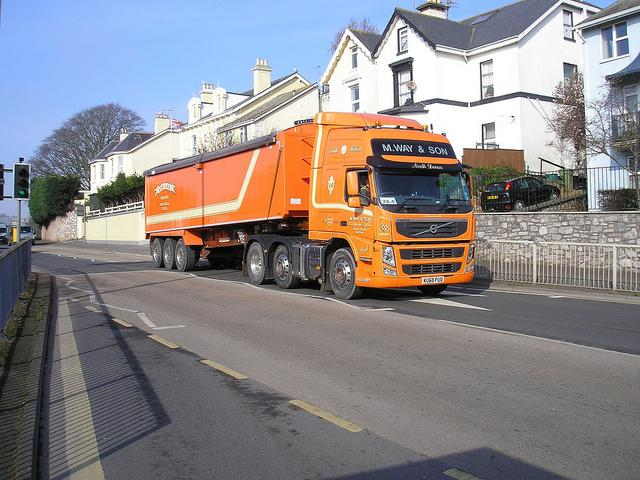What type of truck is this?

Choices:
A) model
B) ladder
C) commercial
D) passenger commercial 